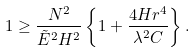<formula> <loc_0><loc_0><loc_500><loc_500>1 \geq \frac { N ^ { 2 } } { \tilde { E } ^ { 2 } H ^ { 2 } } \left \{ 1 + \frac { 4 H r ^ { 4 } } { \lambda ^ { 2 } C } \right \} .</formula> 